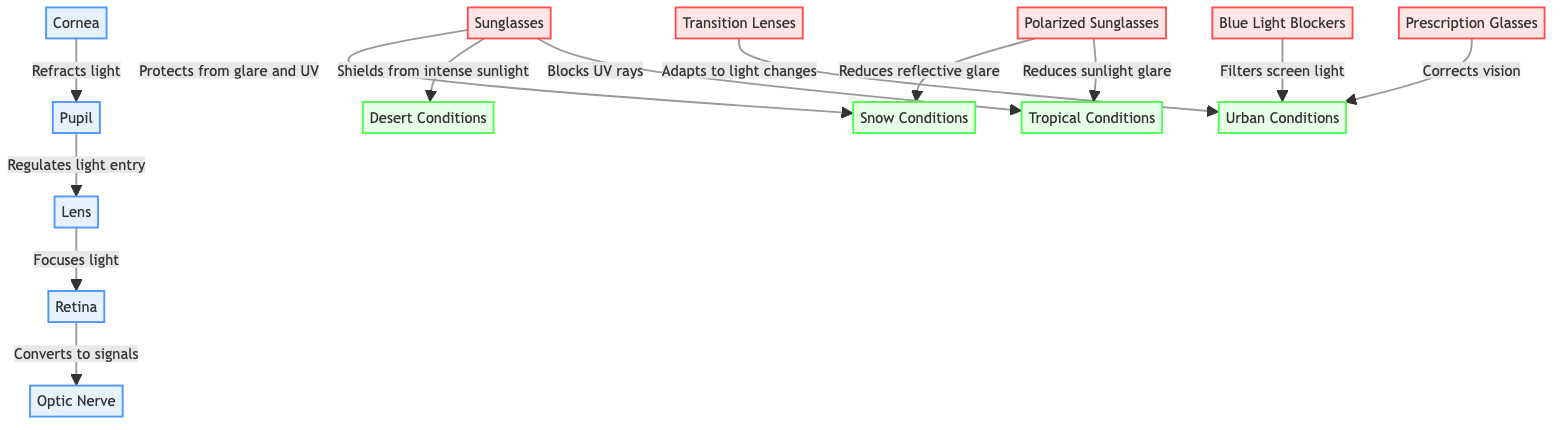What are the main parts of the human eye depicted in the diagram? The diagram shows five main parts of the human eye: Cornea, Pupil, Lens, Retina, and Optic Nerve. Each is clearly labeled, making it easy to identify them as the core components of the eye's anatomy.
Answer: Cornea, Pupil, Lens, Retina, Optic Nerve How many types of eyewear are included in the diagram? There are five different types of eyewear represented in the diagram: Sunglasses, Prescription Glasses, Polarized Sunglasses, Transition Lenses, and Blue Light Blockers. This count is derived from simply counting the labeled eyewear nodes in the diagram.
Answer: 5 What is the primary function of the lens? The lens focuses light, which is important for clear vision. As shown in the diagram, it directly follows the pupil and plays a crucial role in directing light onto the retina.
Answer: Focuses light Which eyewear is recommended for reducing reflective glare in snow conditions? Polarized Sunglasses and Sunglasses are both indicated as effective for reducing reflective glare in snow conditions, as noted in the connections shown in the diagram.
Answer: Polarized Sunglasses, Sunglasses What are the effects of transition lenses according to the diagram? Transition Lenses adapt to light changes, providing versatility in varying light conditions, which is illustrated by their connection to urban conditions where light levels frequently change.
Answer: Adapts to light changes How does the optic nerve relate to the retina? The optic nerve converts signals from the retina, indicating that the retina's role is to send visual signals to the optic nerve, a vital part of how vision is processed.
Answer: Converts to signals Which eyewear is specifically designed to filter screen light? Blue Light Blockers are specifically designed to filter screen light, as indicated in the diagram's connection to urban conditions where screen use is prevalent.
Answer: Blue Light Blockers What effect do sunglasses have in desert conditions? Sunglasses shield from intense sunlight in desert conditions, protecting the eyes from harmful UV rays and providing comfort in bright environments, as stated in the connections in the diagram.
Answer: Shields from intense sunlight Which ocular structure regulates light entry? The pupil regulates light entry into the eye, as it works with the cornea and lens to ensure appropriate light levels reach the retina for optimal vision.
Answer: Regulates light entry 